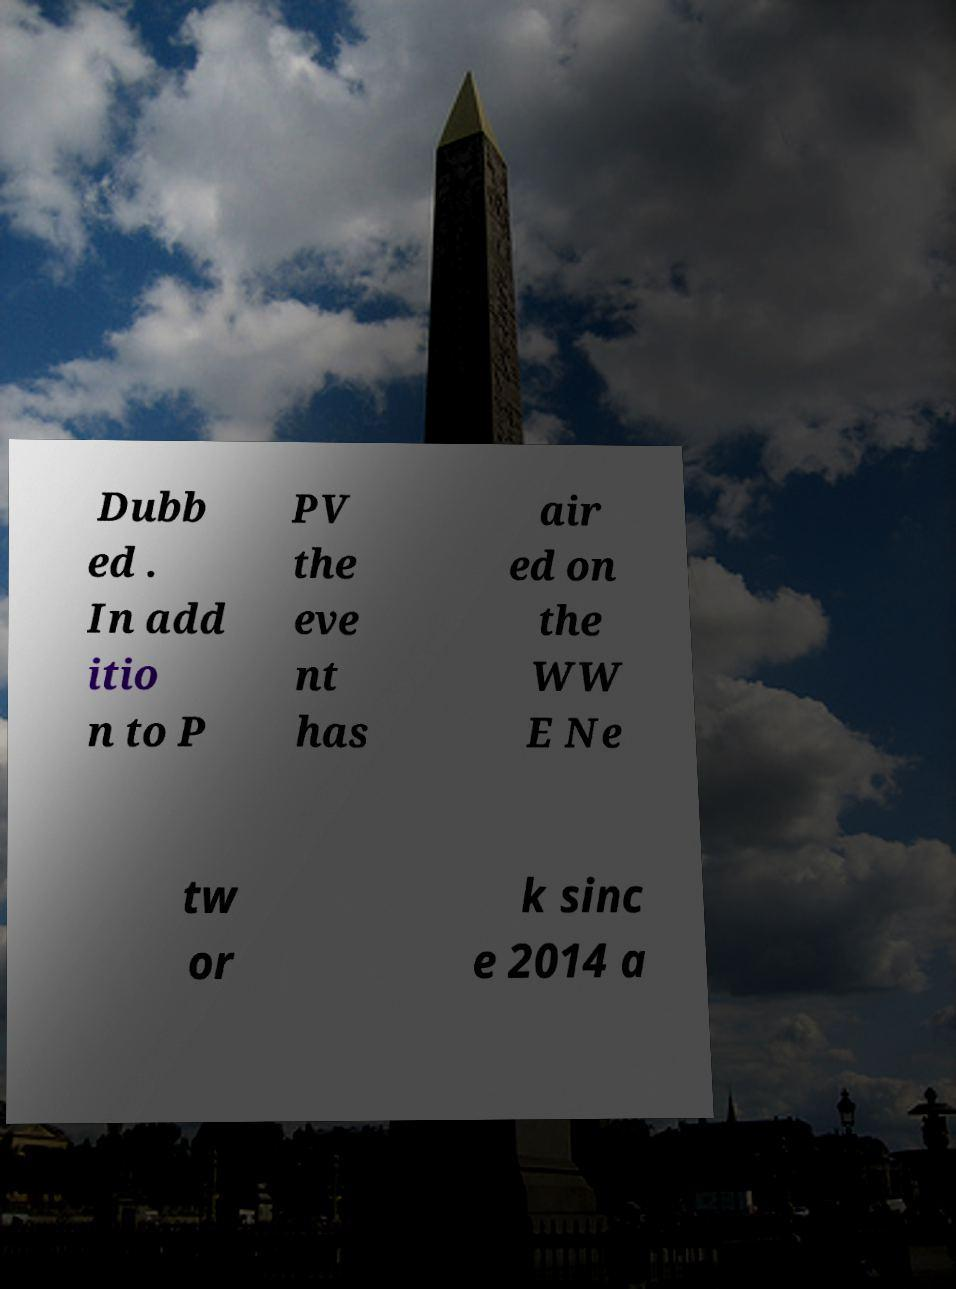Please read and relay the text visible in this image. What does it say? Dubb ed . In add itio n to P PV the eve nt has air ed on the WW E Ne tw or k sinc e 2014 a 